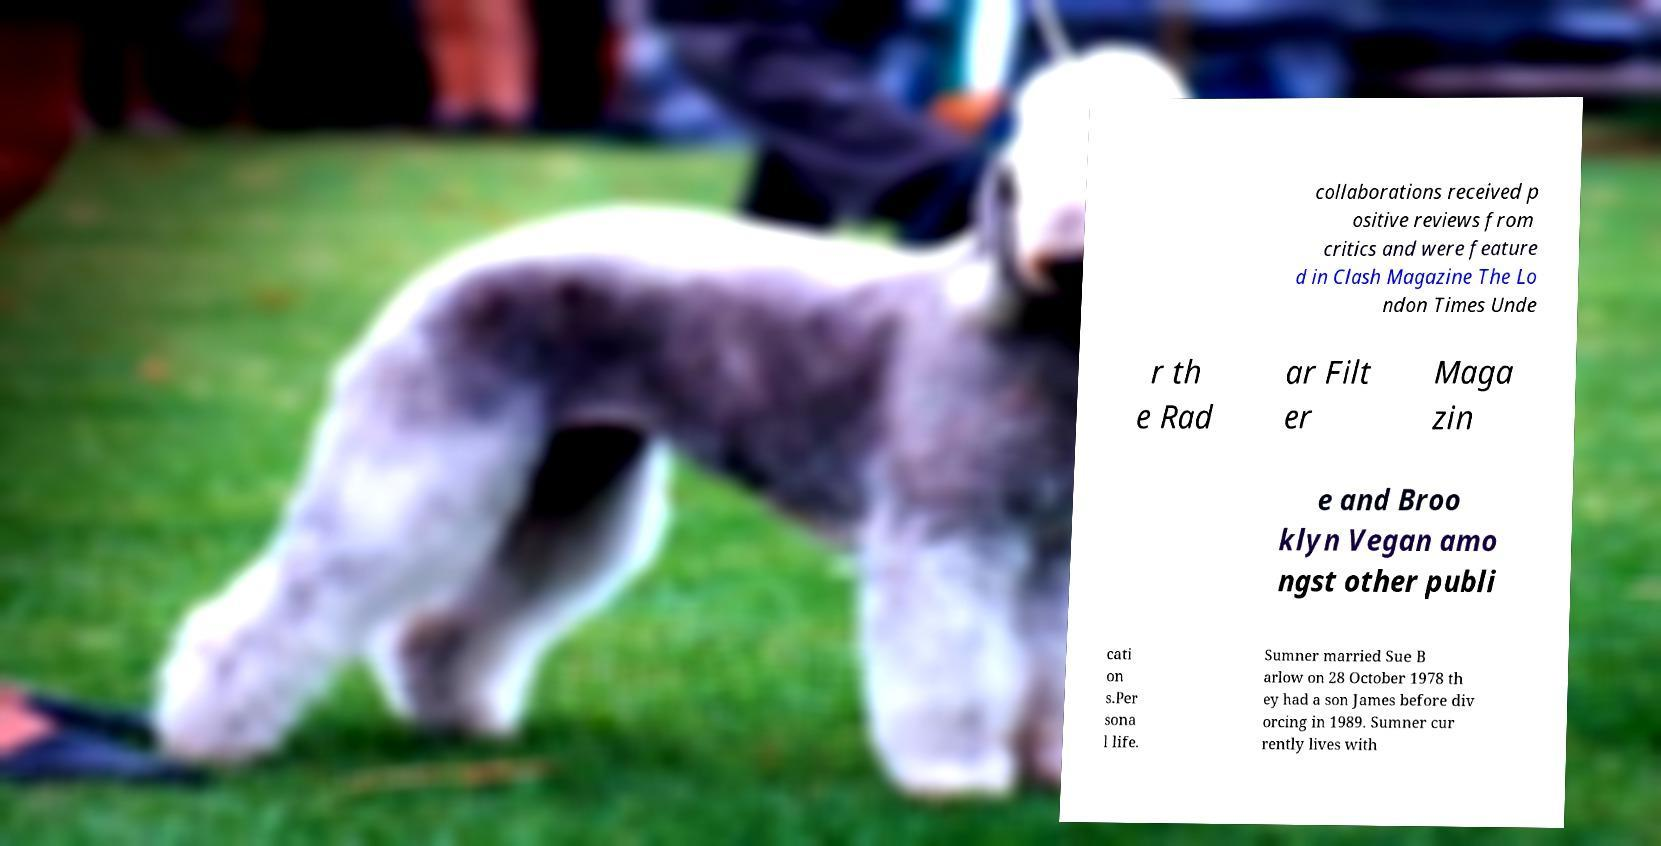What messages or text are displayed in this image? I need them in a readable, typed format. collaborations received p ositive reviews from critics and were feature d in Clash Magazine The Lo ndon Times Unde r th e Rad ar Filt er Maga zin e and Broo klyn Vegan amo ngst other publi cati on s.Per sona l life. Sumner married Sue B arlow on 28 October 1978 th ey had a son James before div orcing in 1989. Sumner cur rently lives with 